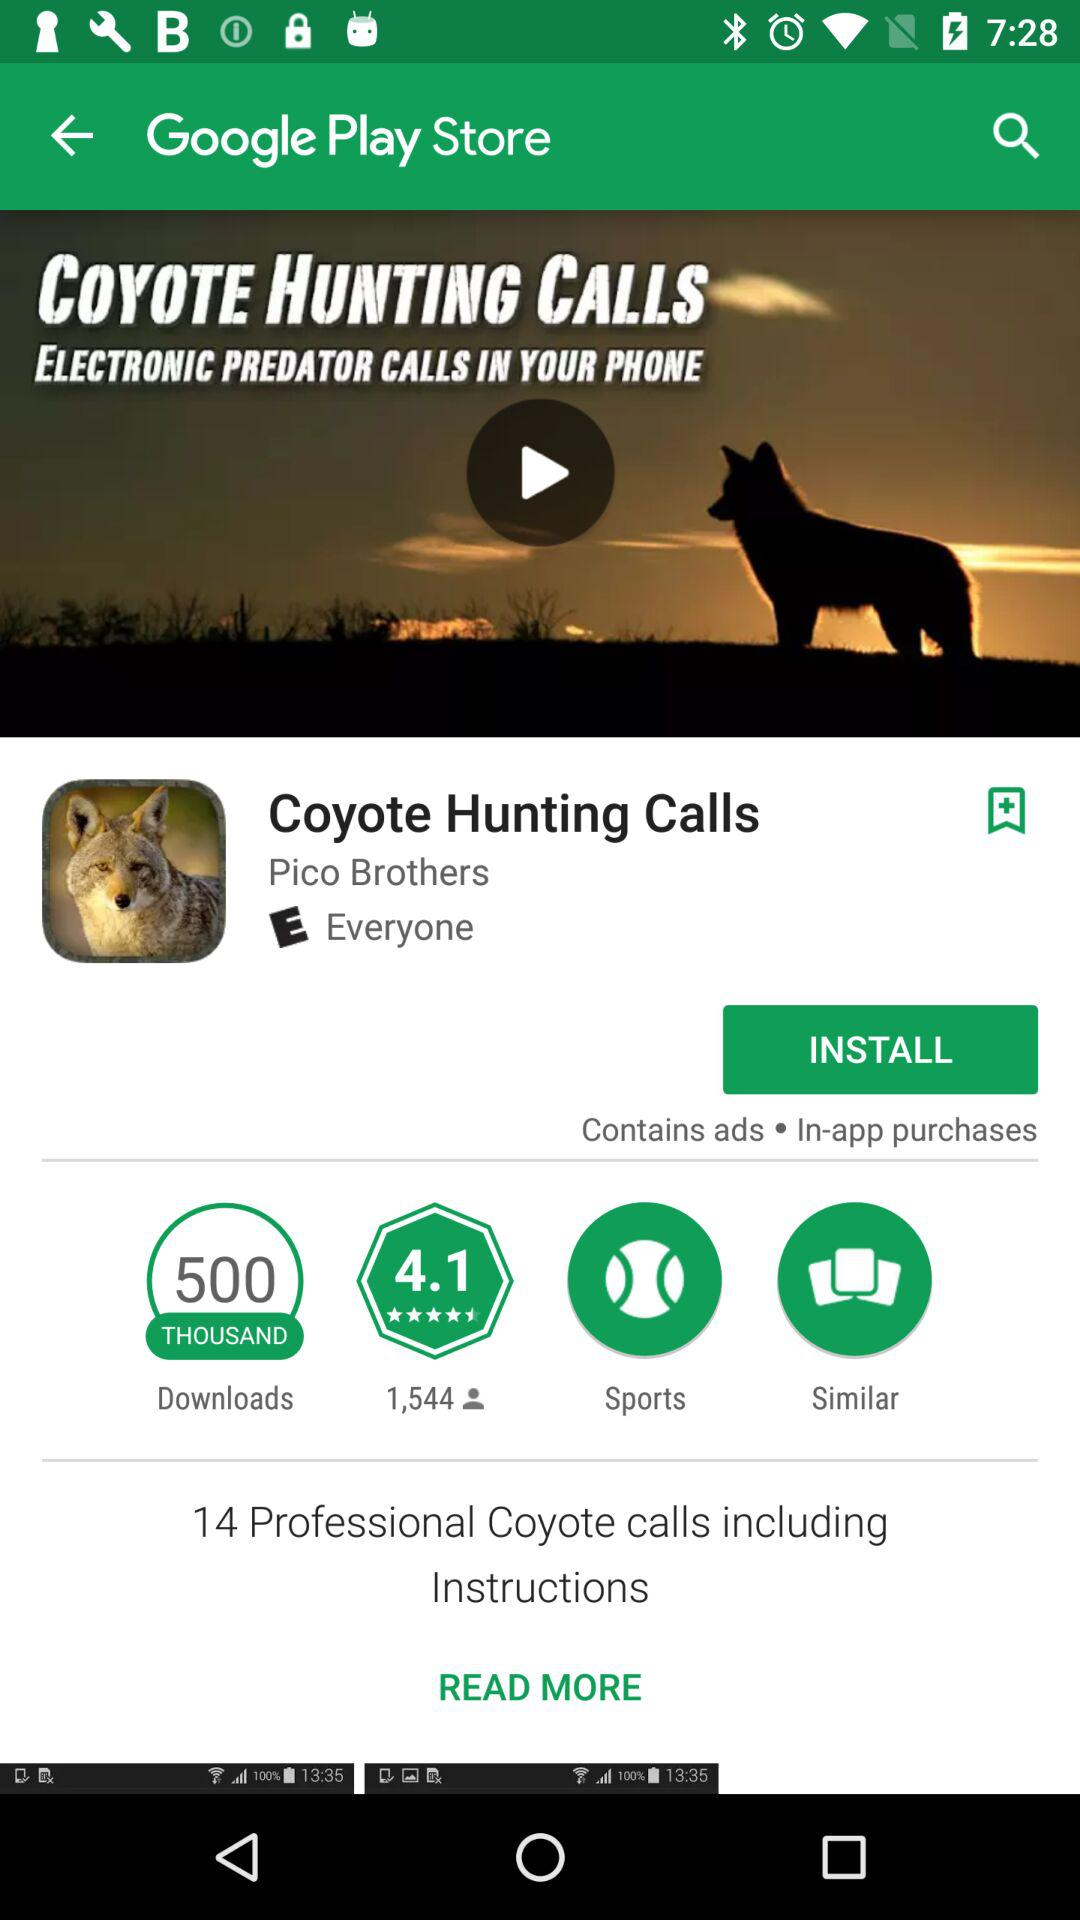How much popular is the application?
When the provided information is insufficient, respond with <no answer>. <no answer> 